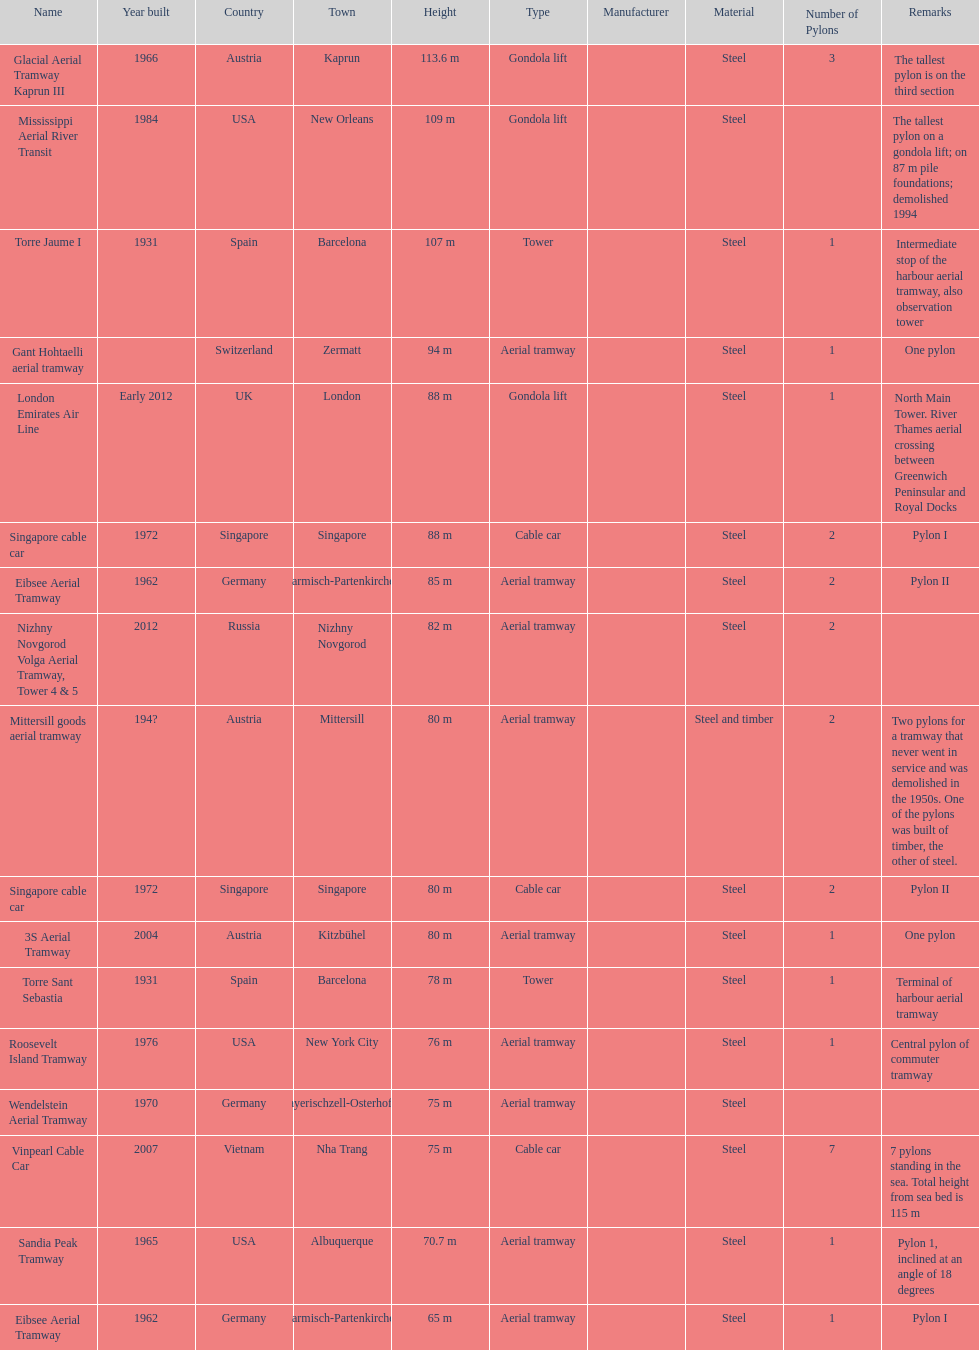What is the total number of pylons listed? 17. 